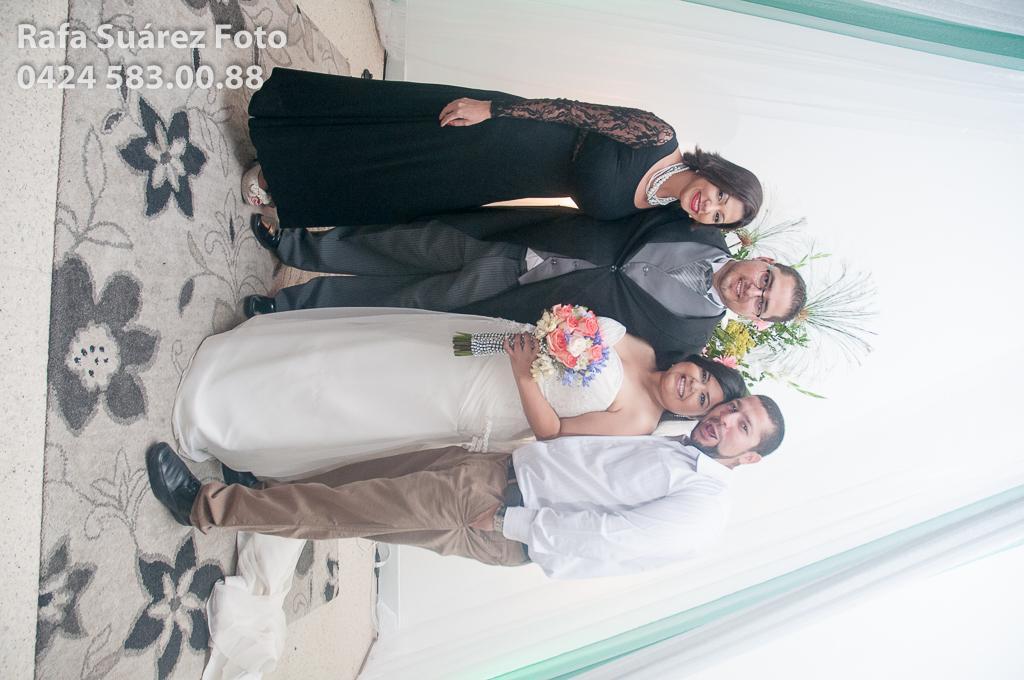Describe this image in one or two sentences. In this image there are a group of people standing with a smile on their face and a woman is holding a bouquet in her hand, behind them there is a plant and curtains, on the top left of the image there is text and numbers, on the floor there is a mat. 